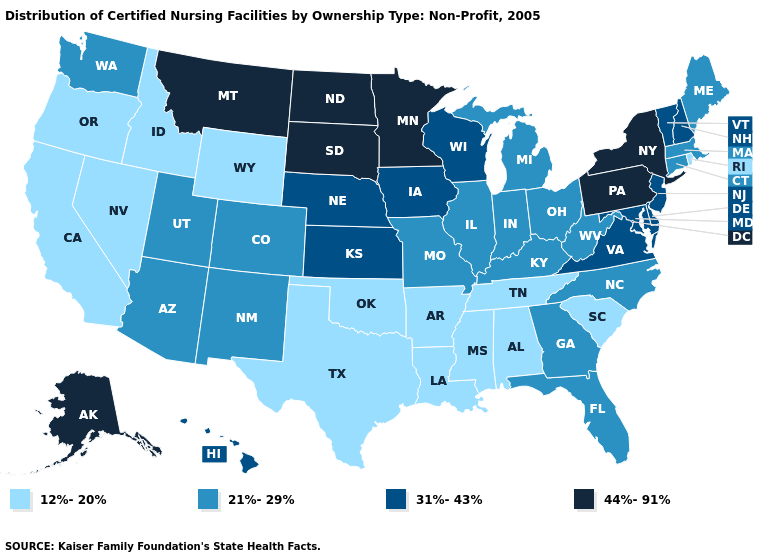Name the states that have a value in the range 21%-29%?
Quick response, please. Arizona, Colorado, Connecticut, Florida, Georgia, Illinois, Indiana, Kentucky, Maine, Massachusetts, Michigan, Missouri, New Mexico, North Carolina, Ohio, Utah, Washington, West Virginia. What is the lowest value in the West?
Quick response, please. 12%-20%. Which states have the lowest value in the USA?
Answer briefly. Alabama, Arkansas, California, Idaho, Louisiana, Mississippi, Nevada, Oklahoma, Oregon, Rhode Island, South Carolina, Tennessee, Texas, Wyoming. Does the first symbol in the legend represent the smallest category?
Quick response, please. Yes. What is the value of Minnesota?
Concise answer only. 44%-91%. Does Massachusetts have a lower value than Minnesota?
Quick response, please. Yes. Does Washington have the lowest value in the West?
Give a very brief answer. No. Does Delaware have the highest value in the South?
Answer briefly. Yes. How many symbols are there in the legend?
Be succinct. 4. What is the value of Arizona?
Quick response, please. 21%-29%. Name the states that have a value in the range 44%-91%?
Quick response, please. Alaska, Minnesota, Montana, New York, North Dakota, Pennsylvania, South Dakota. Among the states that border Ohio , does Indiana have the lowest value?
Concise answer only. Yes. Does the first symbol in the legend represent the smallest category?
Answer briefly. Yes. What is the value of Wyoming?
Be succinct. 12%-20%. Does New Jersey have the same value as Illinois?
Be succinct. No. 